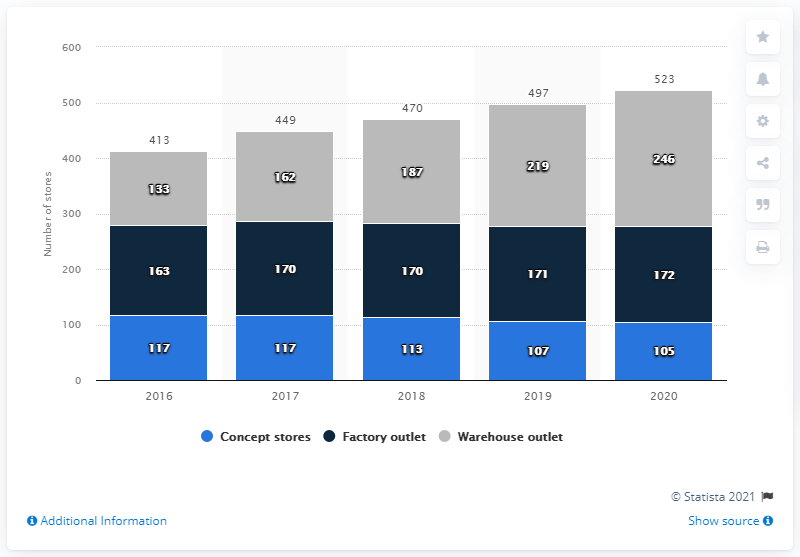Outline some significant characteristics in this image. In 2018, the total number of sketcher stores was 470. The average number of concept stores is 111.8. In 2019, Skechers had a total of 107 concept stores in the United States. 